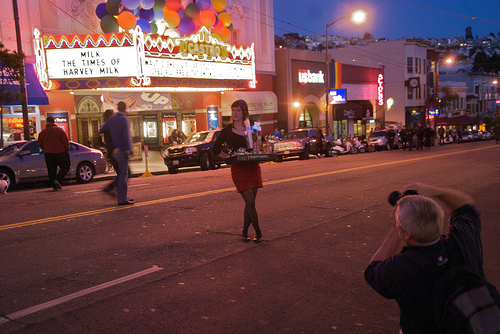<image>
Is there a ballons behind the woman? Yes. From this viewpoint, the ballons is positioned behind the woman, with the woman partially or fully occluding the ballons. Is there a man behind the car? No. The man is not behind the car. From this viewpoint, the man appears to be positioned elsewhere in the scene. Is the girl in the road? Yes. The girl is contained within or inside the road, showing a containment relationship. Is there a lady in the street? Yes. The lady is contained within or inside the street, showing a containment relationship. Is the women in front of the man? Yes. The women is positioned in front of the man, appearing closer to the camera viewpoint. 